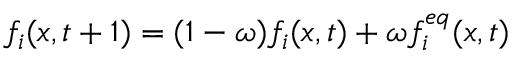<formula> <loc_0><loc_0><loc_500><loc_500>f _ { i } ( x , t + 1 ) = ( 1 - \omega ) f _ { i } ( x , t ) + \omega f _ { i } ^ { e q } ( x , t )</formula> 